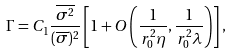<formula> <loc_0><loc_0><loc_500><loc_500>& \Gamma = C _ { 1 } \frac { \overline { \sigma ^ { 2 } } } { ( \overline { \sigma } ) ^ { 2 } } \left [ 1 + O \left ( \frac { 1 } { r _ { 0 } ^ { 2 } \eta } , \frac { 1 } { r _ { 0 } ^ { 2 } \lambda } \right ) \right ] ,</formula> 